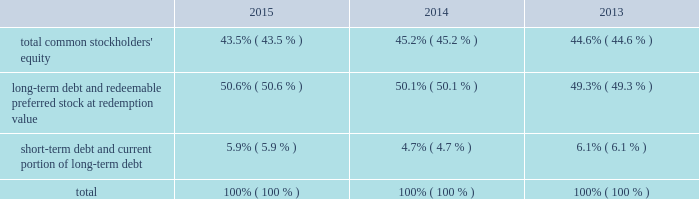The facility is considered 201cdebt 201d for purposes of a support agreement between american water and awcc , which serves as a functional equivalent of a guarantee by american water of awcc 2019s payment obligations under the credit facility .
Also , the company acquired an additional revolving line of credit as part of its keystone acquisition .
The total commitment under this credit facility was $ 16 million of which $ 2 million was outstanding as of december 31 , 2015 .
The table summarizes information regarding the company 2019s aggregate credit facility commitments , letter of credit sub-limits and available funds under those revolving credit facilities , as well as outstanding amounts of commercial paper and outstanding borrowings under the respective facilities as of december 31 , 2015 and 2014 : credit facility commitment available credit facility capacity letter of credit sublimit available letter of credit capacity outstanding commercial ( net of discount ) credit line borrowing ( in millions ) december 31 , 2015 .
$ 1266 $ 1182 $ 150 $ 68 $ 626 $ 2 december 31 , 2014 .
$ 1250 $ 1212 $ 150 $ 112 $ 450 $ 2014 the weighted-average interest rate on awcc short-term borrowings for the years ended december 31 , 2015 and 2014 was approximately 0.49% ( 0.49 % ) and 0.31% ( 0.31 % ) , respectively .
Interest accrues on the keystone revolving line of credit daily at a rate per annum equal to 2.75% ( 2.75 % ) above the greater of the one month or one day libor .
Capital structure the table indicates the percentage of our capitalization represented by the components of our capital structure as of december 31: .
The changes in the capital structure between periods were mainly attributable to changes in outstanding commercial paper balances .
Debt covenants our debt agreements contain financial and non-financial covenants .
To the extent that we are not in compliance with these covenants such an event may create an event of default under the debt agreement and we or our subsidiaries may be restricted in our ability to pay dividends , issue new debt or access our revolving credit facility .
For two of our smaller operating companies , we have informed our counterparties that we will provide only unaudited financial information at the subsidiary level , which resulted in technical non-compliance with certain of their reporting requirements under debt agreements with respect to $ 8 million of outstanding debt .
We do not believe this event will materially impact us .
Our long-term debt indentures contain a number of covenants that , among other things , limit the company from issuing debt secured by the company 2019s assets , subject to certain exceptions .
Our failure to comply with any of these covenants could accelerate repayment obligations .
Certain long-term notes and the revolving credit facility require us to maintain a ratio of consolidated debt to consolidated capitalization ( as defined in the relevant documents ) of not more than 0.70 to 1.00 .
On december 31 , 2015 , our ratio was 0.56 to 1.00 and therefore we were in compliance with the covenant. .
By how much did the short-term debt and current portion of long-term debt portion of the company's capital structure decrease from 2013 to 2015? 
Computations: (5.9% - 6.1%)
Answer: -0.002. 